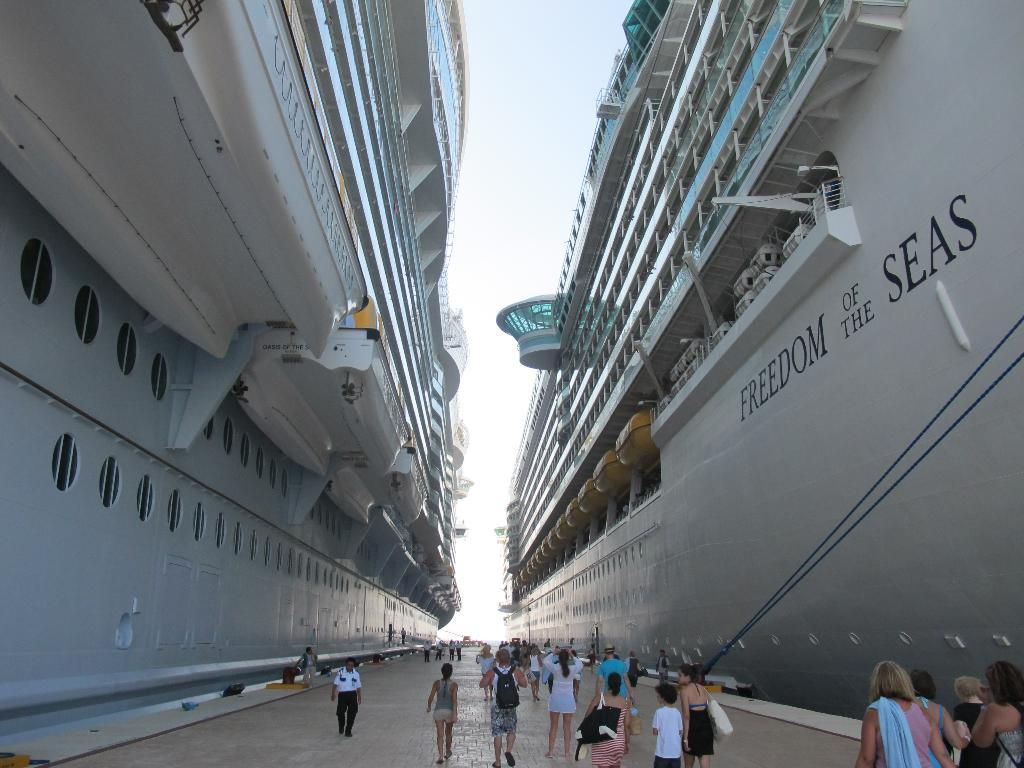<image>
Give a short and clear explanation of the subsequent image. The Freedom of the Seas cruise shipped docked next to another cruise ship. 